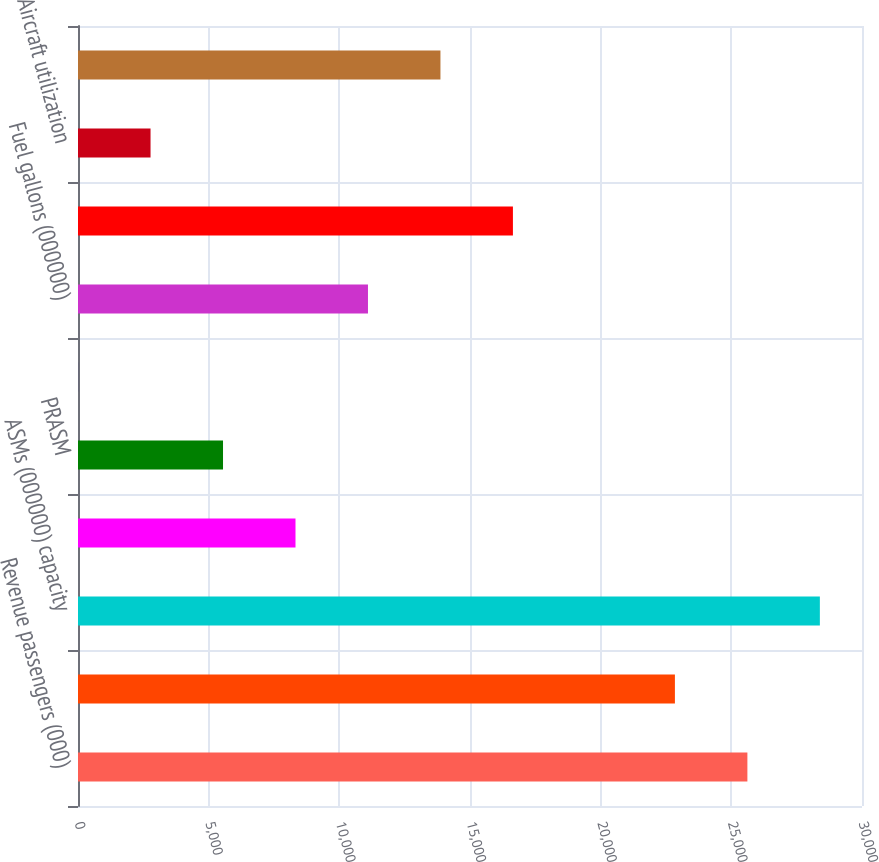Convert chart. <chart><loc_0><loc_0><loc_500><loc_500><bar_chart><fcel>Revenue passengers (000)<fcel>RPMs (000000) traffic<fcel>ASMs (000000) capacity<fcel>Yield<fcel>PRASM<fcel>Economic fuel cost per gallon<fcel>Fuel gallons (000000)<fcel>Average number of full-time<fcel>Aircraft utilization<fcel>Average aircraft stage length<nl><fcel>25614.4<fcel>22841<fcel>28387.7<fcel>8322.45<fcel>5549.09<fcel>2.37<fcel>11095.8<fcel>16642.5<fcel>2775.73<fcel>13869.2<nl></chart> 